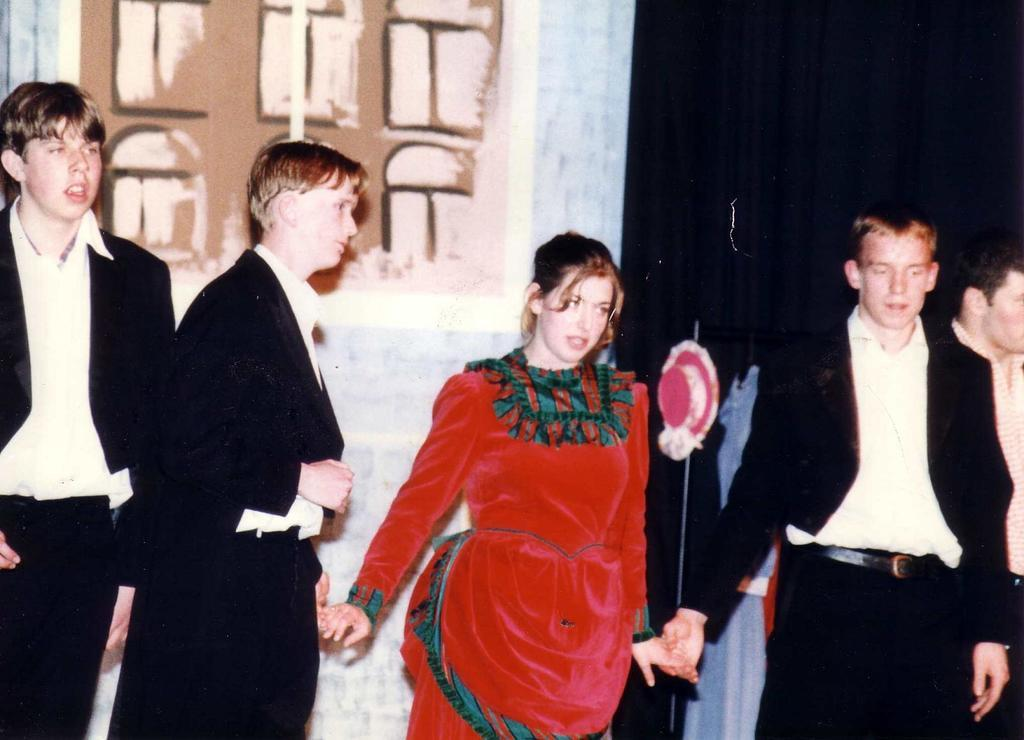Who is the main subject in the image? There is a woman in the middle of the image. What is the woman wearing? The woman is wearing a red dress. Who are the other people in the image? There are men standing on either side of the woman. What are the men wearing? The men are wearing black color coats. What type of floor can be seen in the image? There is no information about the floor in the image, as the focus is on the people and their clothing. 